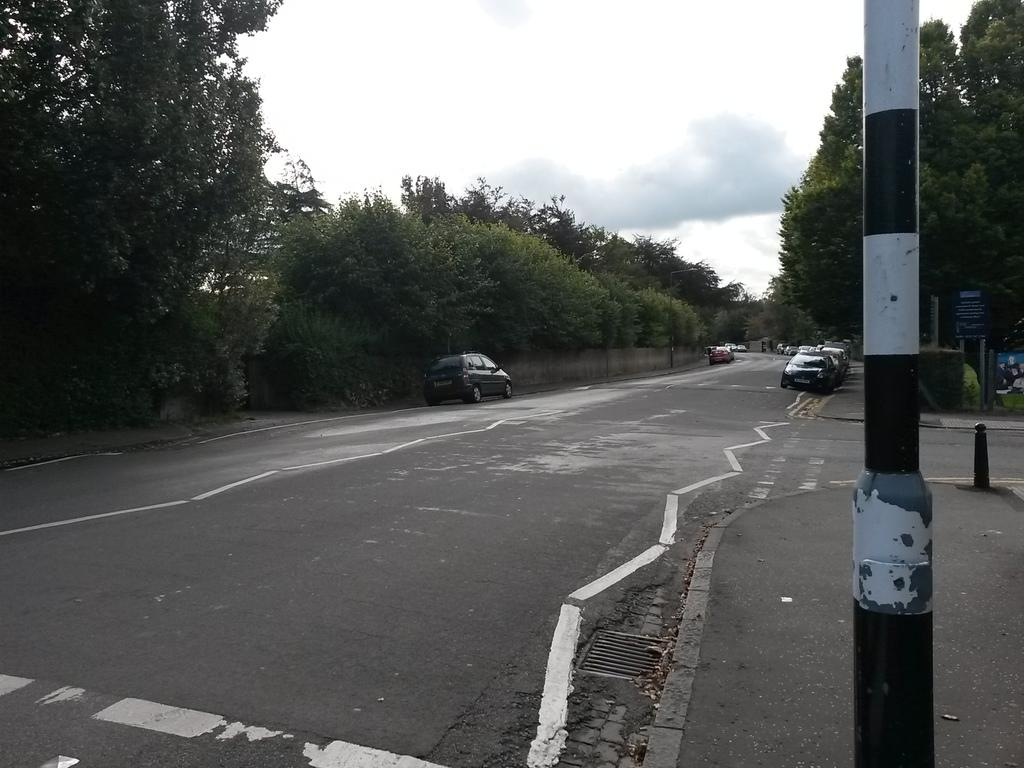What type of natural elements can be seen in the image? There are trees in the image. What type of man-made structures are present in the image? There are vehicles on the road and poles in the image. What can be seen in the background of the image? The sky is visible in the background of the image. Can you see a table in the image? There is no table present in the image. Are there any yams visible in the image? There are no yams present in the image. 